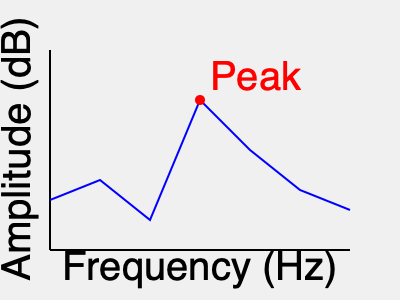In the frequency spectrum of Mal Waldron's iconic solo on "Left Alone," what is the approximate frequency of the most prominent peak, and how might this reflect his unique approach to piano playing? To answer this question, let's analyze the frequency spectrum graph step-by-step:

1. The x-axis represents frequency in Hz, ranging from low to high frequencies.
2. The y-axis represents amplitude in dB, indicating the strength of each frequency component.
3. The blue line represents the frequency spectrum of Mal Waldron's solo.
4. The red circle highlights the most prominent peak in the spectrum.

Looking at the graph:
1. The x-axis is divided into 6 equal segments, spanning from 50 Hz to 350 Hz.
2. Each segment represents (350 Hz - 50 Hz) / 6 = 50 Hz.
3. The prominent peak (red circle) is located at the 3rd segment from the left.
4. This corresponds to approximately 50 Hz + (3 * 50 Hz) = 200 Hz.

Mal Waldron, an often underappreciated jazz pianist, was known for his minimalist and repetitive style. The prominent peak at around 200 Hz could reflect:

1. His focus on the middle register of the piano.
2. A preference for resonant, sustaining notes in this frequency range.
3. The use of repetitive patterns or ostinatos that emphasize this particular frequency.

This approach aligns with Waldron's reputation for creating hypnotic, trance-like solos that prioritize rhythm and texture over flashy technical displays. The concentration of energy around 200 Hz suggests a deliberate choice to explore the piano's warm, resonant middle range, contributing to his unique and often overlooked style in jazz piano playing.
Answer: 200 Hz, reflecting Waldron's minimalist, middle-register focused style 